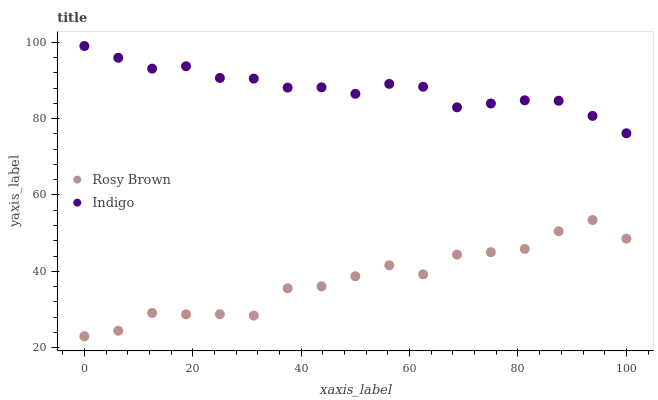Does Rosy Brown have the minimum area under the curve?
Answer yes or no. Yes. Does Indigo have the maximum area under the curve?
Answer yes or no. Yes. Does Indigo have the minimum area under the curve?
Answer yes or no. No. Is Indigo the smoothest?
Answer yes or no. Yes. Is Rosy Brown the roughest?
Answer yes or no. Yes. Is Indigo the roughest?
Answer yes or no. No. Does Rosy Brown have the lowest value?
Answer yes or no. Yes. Does Indigo have the lowest value?
Answer yes or no. No. Does Indigo have the highest value?
Answer yes or no. Yes. Is Rosy Brown less than Indigo?
Answer yes or no. Yes. Is Indigo greater than Rosy Brown?
Answer yes or no. Yes. Does Rosy Brown intersect Indigo?
Answer yes or no. No. 